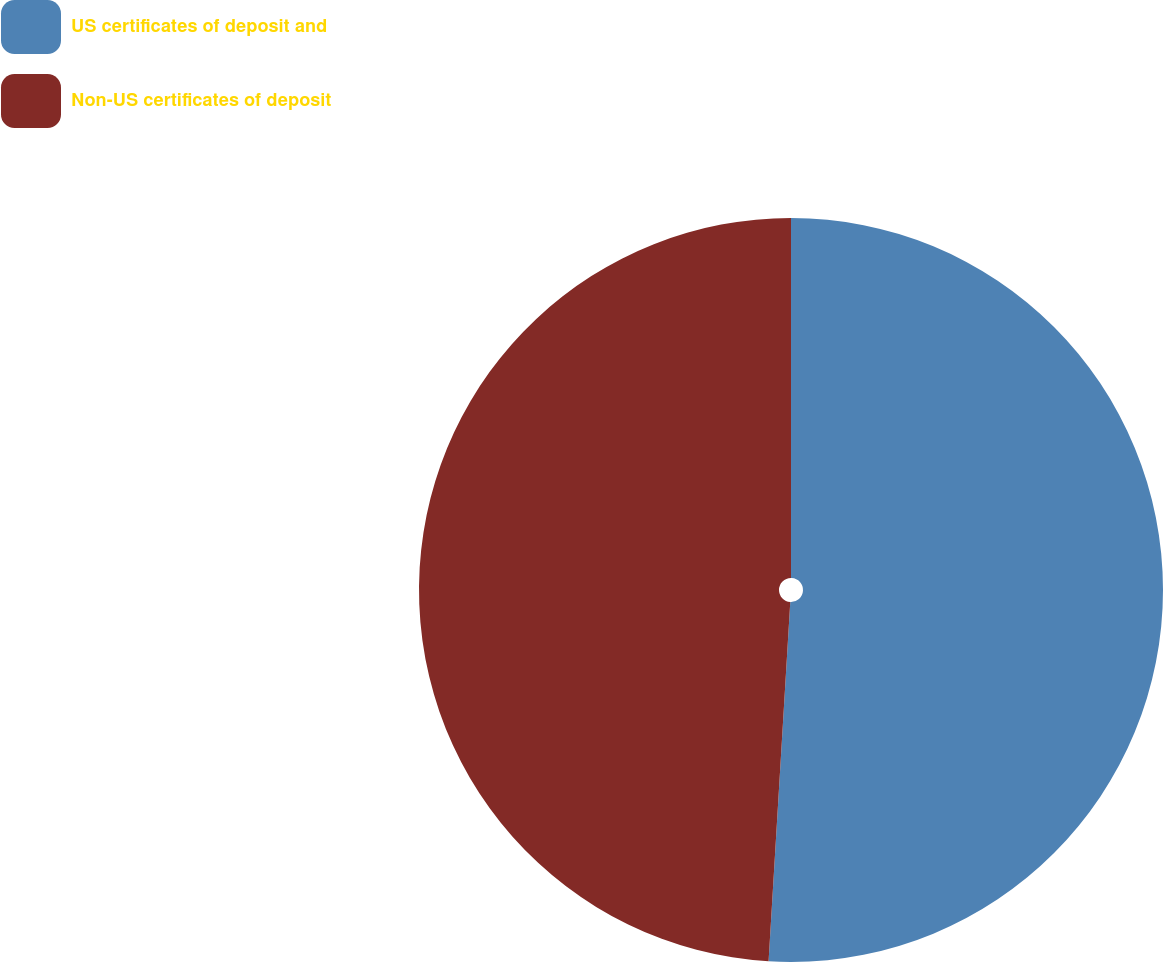Convert chart. <chart><loc_0><loc_0><loc_500><loc_500><pie_chart><fcel>US certificates of deposit and<fcel>Non-US certificates of deposit<nl><fcel>50.96%<fcel>49.04%<nl></chart> 